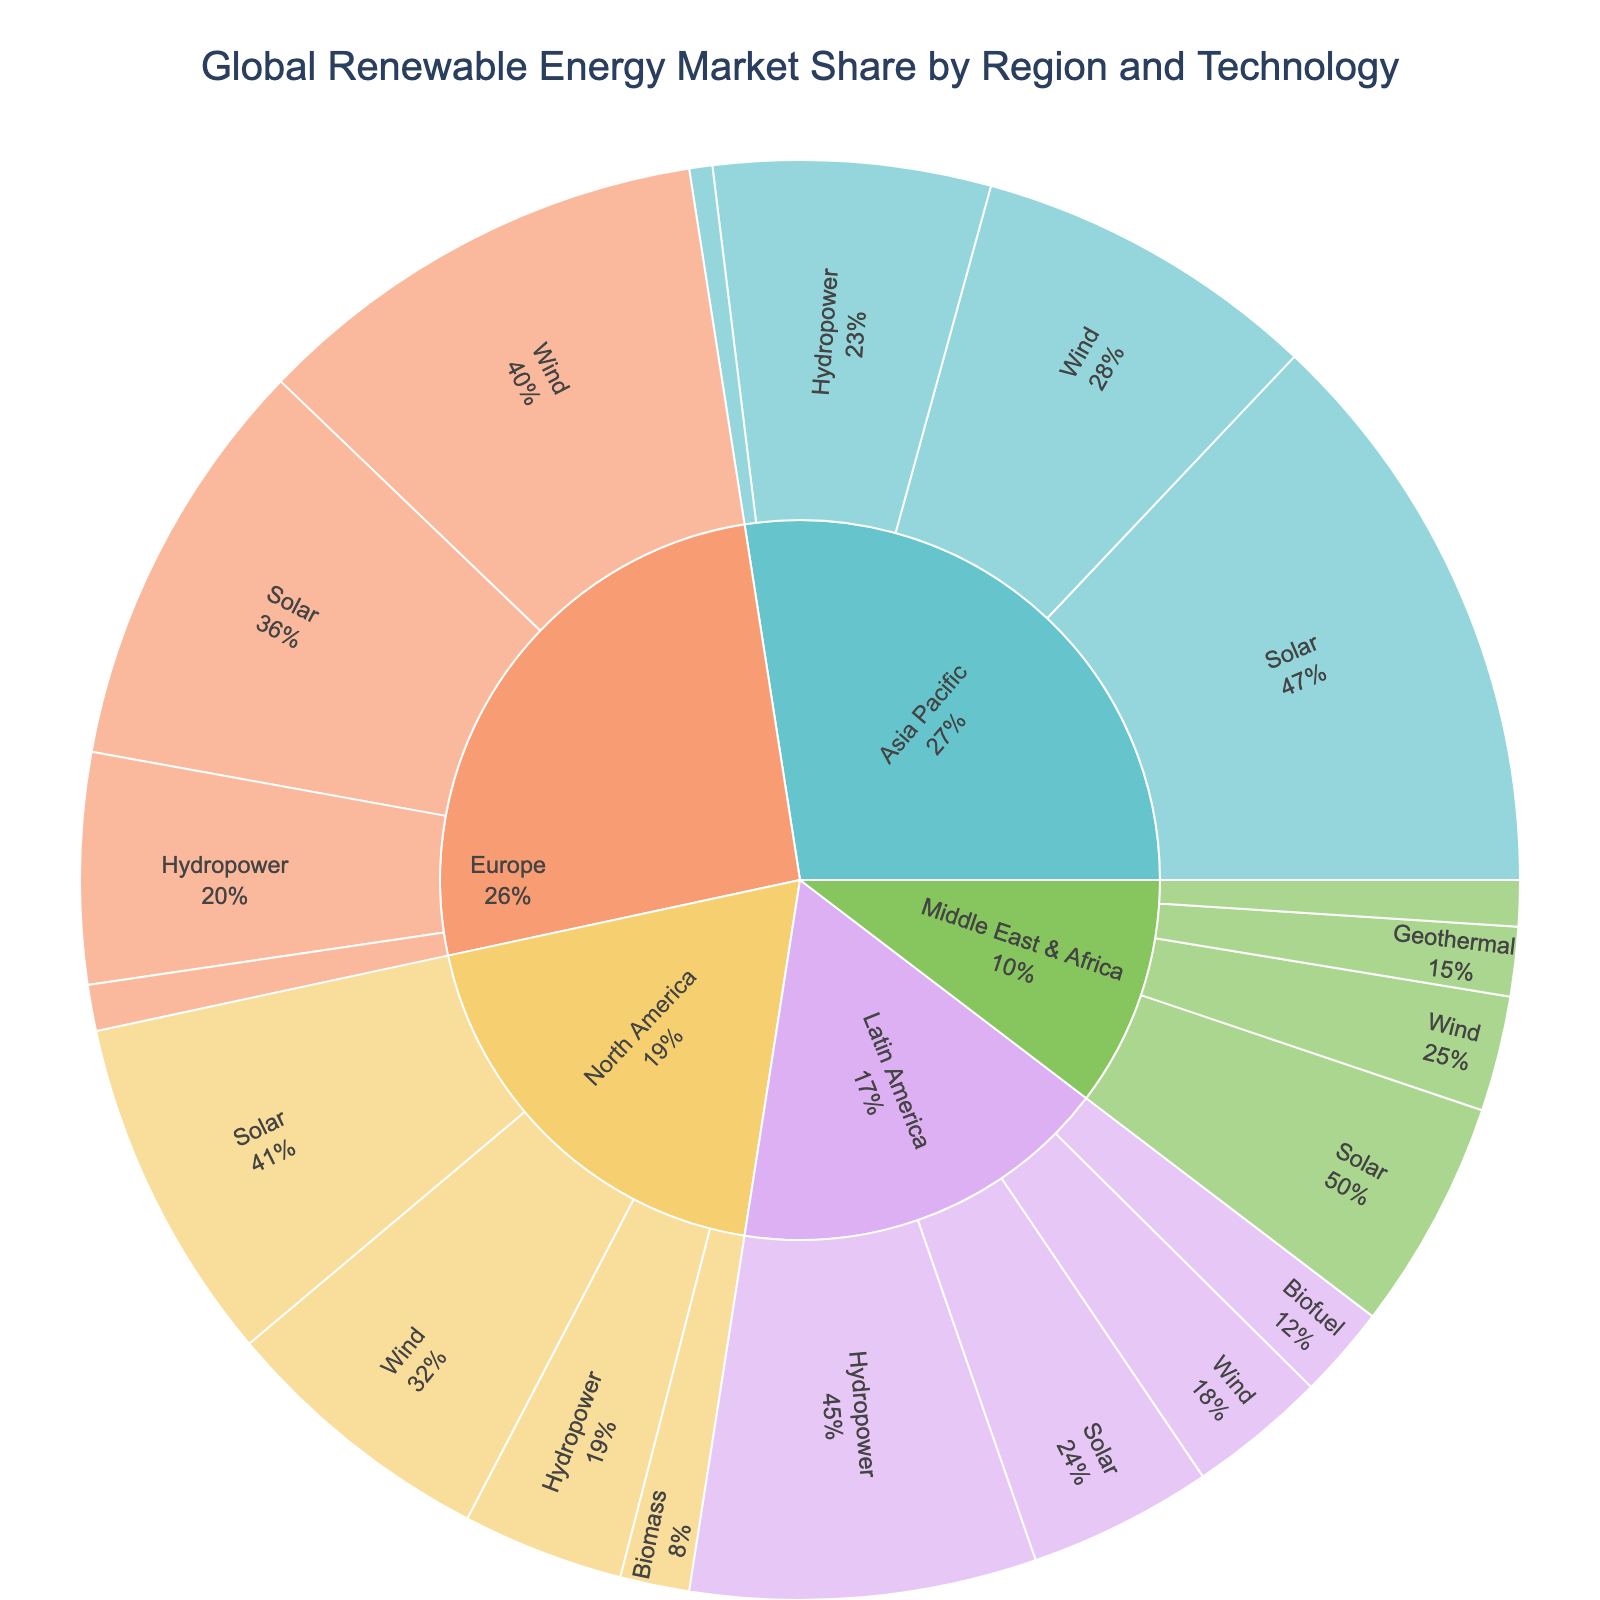What is the title of the figure? The title is located at the top of the figure, typically centered. It summarises what the figure is about.
Answer: Global Renewable Energy Market Share by Region and Technology Which region has the highest market share in Solar technology? Examine the segments under 'Solar' within each region and compare their market shares. The region with the largest Solar segment has the highest share.
Answer: Asia Pacific How much higher is Europe’s market share in Wind technology compared to North America’s? Find the market share for Wind technology in both Europe (20%) and North America (12%). Subtract North America's share from Europe's.
Answer: 8% What percentage of the global renewable energy market share does Hydropower contribute in Latin America? Find the Hydropower segment under Latin America and refer to its value.
Answer: 15% Which technology has the lowest market share in the Asia Pacific region? Examine the segments under 'Asia Pacific' and find the technology with the smallest market share, which is Tidal with 1%.
Answer: Tidal Which region has a market share in Geothermal energy, and how does it compare to its use in other regions? Observe the Geothermal segments in all regions and compare their values. Middle East & Africa and Europe have 3% and 2% respectively.
Answer: Middle East & Africa has 3%, Europe has 2% What is the combined market share of Solar technology across all regions? Sum the market shares of Solar technology in each region: 15% (North America) + 18% (Europe) + 25% (Asia Pacific) + 8% (Latin America) + 10% (Middle East & Africa).
Answer: 76% Which region has the most diverse usage of renewable energy technologies? Determine the number of different technologies listed under each region, counting the unique categories.
Answer: Europe In Middle East & Africa, what is the ratio of the market share of Wind to Concentrated Solar Power? Divide the market share of Wind (5%) by that of Concentrated Solar Power (2%).
Answer: 2.5:1 Considering the sunburst plot, which technology appears in only one region and what is its market share? Look for technologies that have only one segment across all regions. Biofuel appears only in Latin America with 4%.
Answer: Biofuel, 4% 